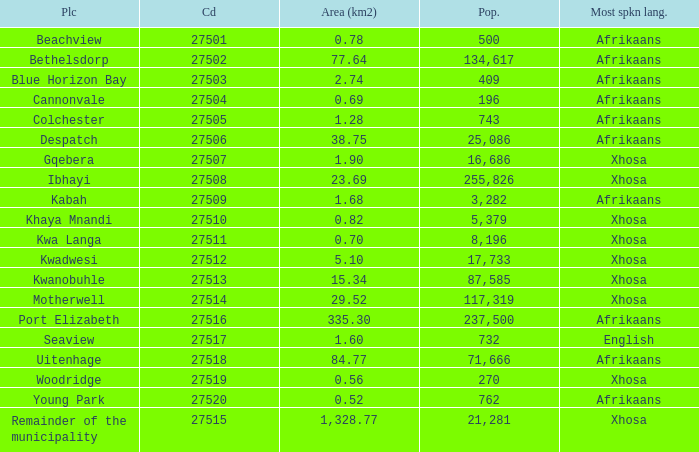What is the total number of area listed for cannonvale with a population less than 409? 1.0. Give me the full table as a dictionary. {'header': ['Plc', 'Cd', 'Area (km2)', 'Pop.', 'Most spkn lang.'], 'rows': [['Beachview', '27501', '0.78', '500', 'Afrikaans'], ['Bethelsdorp', '27502', '77.64', '134,617', 'Afrikaans'], ['Blue Horizon Bay', '27503', '2.74', '409', 'Afrikaans'], ['Cannonvale', '27504', '0.69', '196', 'Afrikaans'], ['Colchester', '27505', '1.28', '743', 'Afrikaans'], ['Despatch', '27506', '38.75', '25,086', 'Afrikaans'], ['Gqebera', '27507', '1.90', '16,686', 'Xhosa'], ['Ibhayi', '27508', '23.69', '255,826', 'Xhosa'], ['Kabah', '27509', '1.68', '3,282', 'Afrikaans'], ['Khaya Mnandi', '27510', '0.82', '5,379', 'Xhosa'], ['Kwa Langa', '27511', '0.70', '8,196', 'Xhosa'], ['Kwadwesi', '27512', '5.10', '17,733', 'Xhosa'], ['Kwanobuhle', '27513', '15.34', '87,585', 'Xhosa'], ['Motherwell', '27514', '29.52', '117,319', 'Xhosa'], ['Port Elizabeth', '27516', '335.30', '237,500', 'Afrikaans'], ['Seaview', '27517', '1.60', '732', 'English'], ['Uitenhage', '27518', '84.77', '71,666', 'Afrikaans'], ['Woodridge', '27519', '0.56', '270', 'Xhosa'], ['Young Park', '27520', '0.52', '762', 'Afrikaans'], ['Remainder of the municipality', '27515', '1,328.77', '21,281', 'Xhosa']]} 